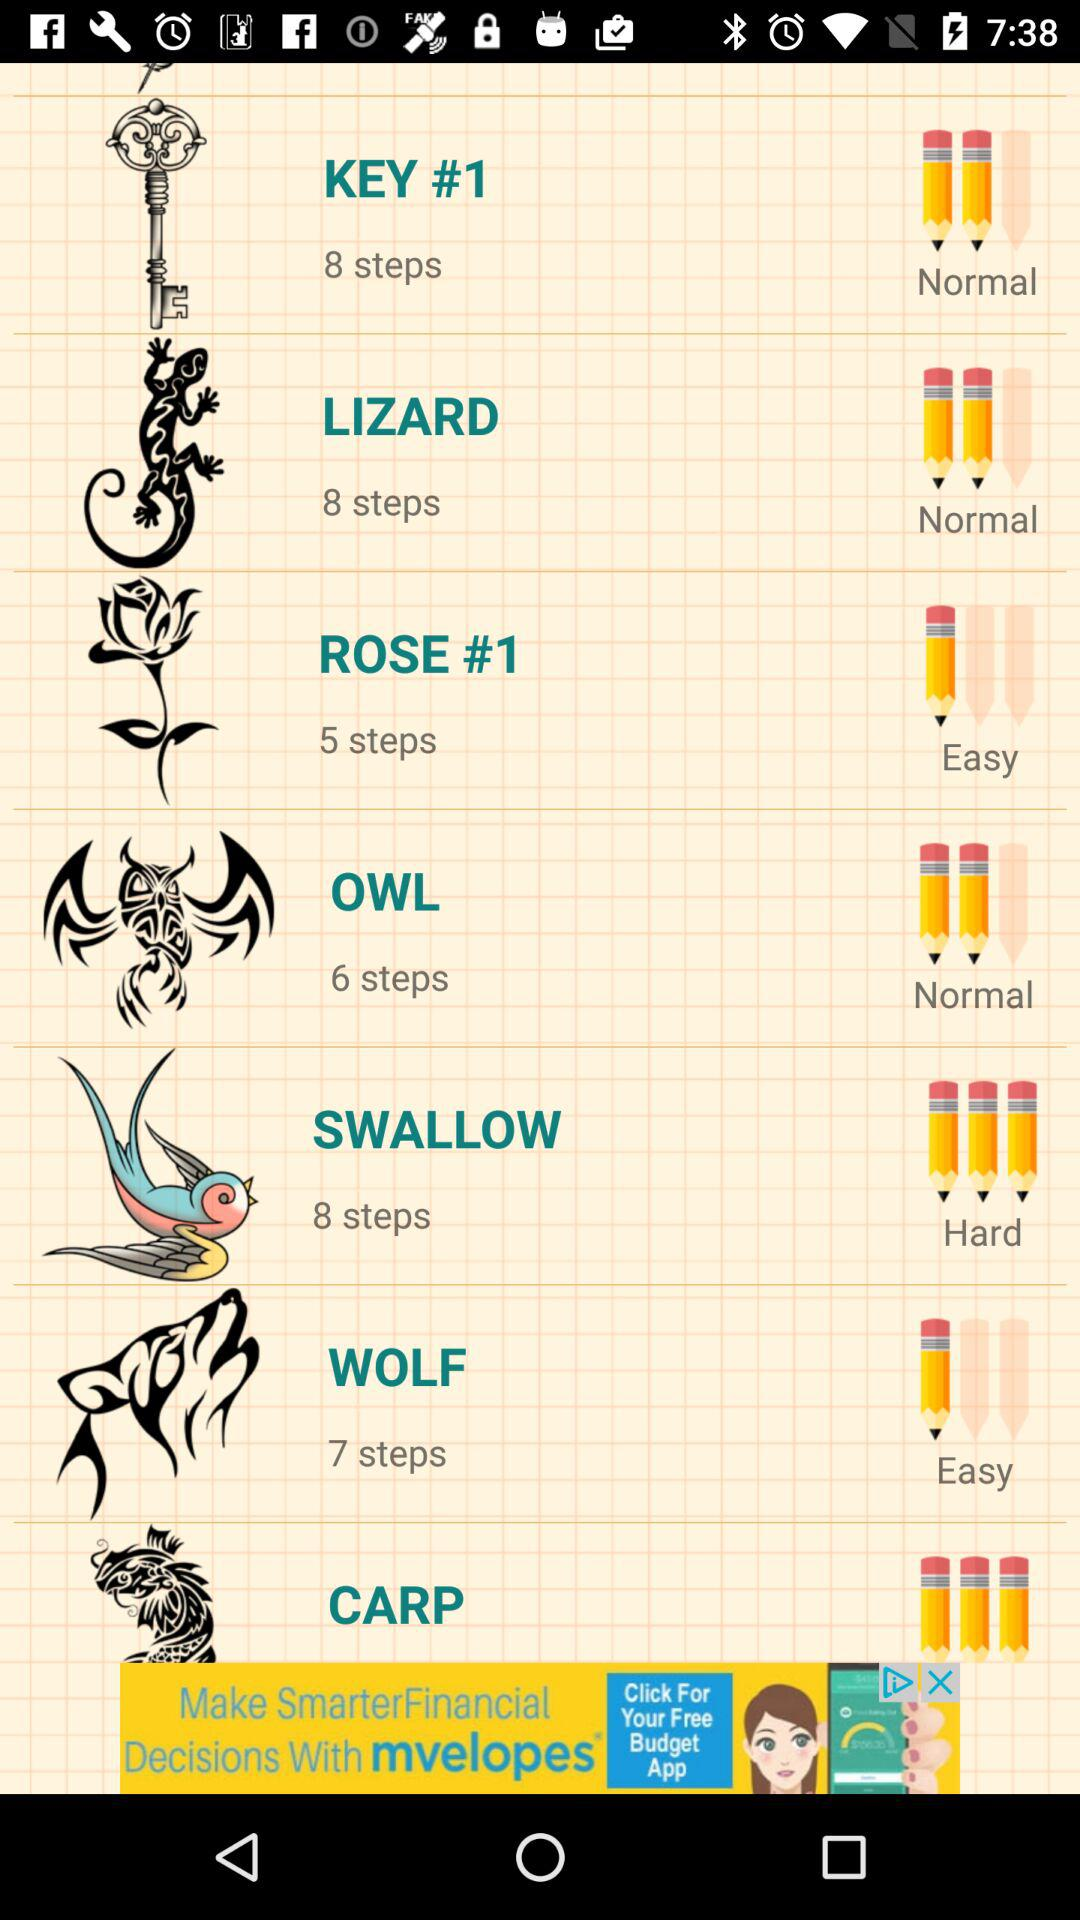How many steps are there for the drawing with the most steps?
Answer the question using a single word or phrase. 8 